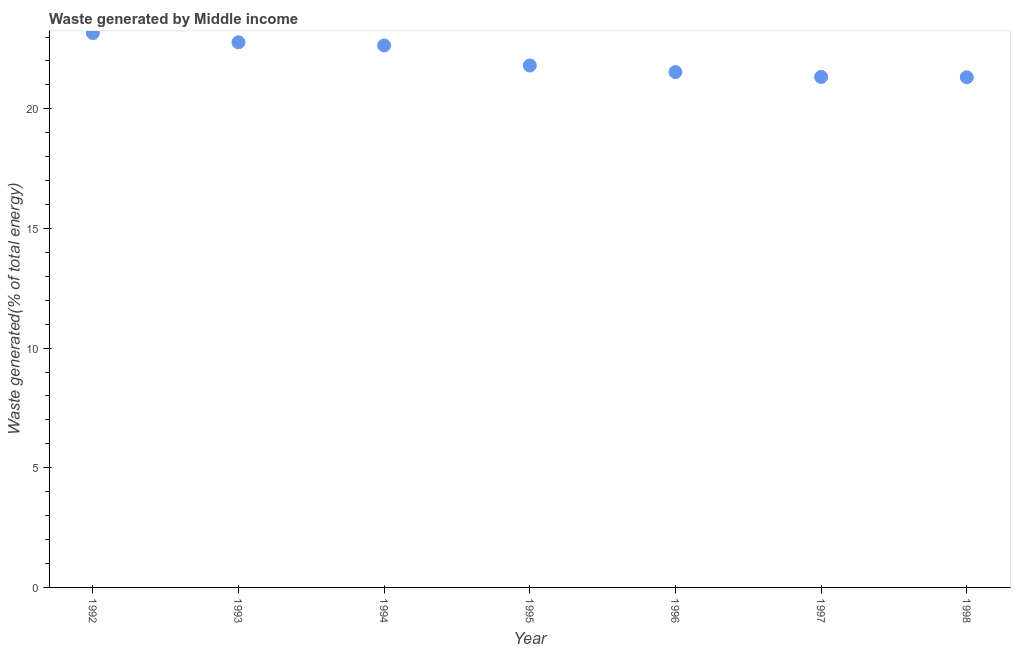What is the amount of waste generated in 1996?
Your response must be concise. 21.54. Across all years, what is the maximum amount of waste generated?
Your response must be concise. 23.17. Across all years, what is the minimum amount of waste generated?
Your answer should be very brief. 21.32. What is the sum of the amount of waste generated?
Provide a short and direct response. 154.59. What is the difference between the amount of waste generated in 1993 and 1998?
Provide a short and direct response. 1.46. What is the average amount of waste generated per year?
Provide a short and direct response. 22.08. What is the median amount of waste generated?
Keep it short and to the point. 21.81. In how many years, is the amount of waste generated greater than 20 %?
Keep it short and to the point. 7. What is the ratio of the amount of waste generated in 1993 to that in 1997?
Your answer should be compact. 1.07. Is the amount of waste generated in 1993 less than that in 1996?
Provide a succinct answer. No. Is the difference between the amount of waste generated in 1993 and 1996 greater than the difference between any two years?
Your answer should be compact. No. What is the difference between the highest and the second highest amount of waste generated?
Keep it short and to the point. 0.39. What is the difference between the highest and the lowest amount of waste generated?
Offer a terse response. 1.85. In how many years, is the amount of waste generated greater than the average amount of waste generated taken over all years?
Your response must be concise. 3. Does the amount of waste generated monotonically increase over the years?
Give a very brief answer. No. How many years are there in the graph?
Your answer should be very brief. 7. Are the values on the major ticks of Y-axis written in scientific E-notation?
Your answer should be compact. No. Does the graph contain any zero values?
Your response must be concise. No. What is the title of the graph?
Keep it short and to the point. Waste generated by Middle income. What is the label or title of the Y-axis?
Your answer should be very brief. Waste generated(% of total energy). What is the Waste generated(% of total energy) in 1992?
Offer a very short reply. 23.17. What is the Waste generated(% of total energy) in 1993?
Provide a short and direct response. 22.78. What is the Waste generated(% of total energy) in 1994?
Keep it short and to the point. 22.65. What is the Waste generated(% of total energy) in 1995?
Your answer should be compact. 21.81. What is the Waste generated(% of total energy) in 1996?
Make the answer very short. 21.54. What is the Waste generated(% of total energy) in 1997?
Your answer should be compact. 21.33. What is the Waste generated(% of total energy) in 1998?
Keep it short and to the point. 21.32. What is the difference between the Waste generated(% of total energy) in 1992 and 1993?
Give a very brief answer. 0.39. What is the difference between the Waste generated(% of total energy) in 1992 and 1994?
Give a very brief answer. 0.52. What is the difference between the Waste generated(% of total energy) in 1992 and 1995?
Your response must be concise. 1.36. What is the difference between the Waste generated(% of total energy) in 1992 and 1996?
Make the answer very short. 1.63. What is the difference between the Waste generated(% of total energy) in 1992 and 1997?
Offer a terse response. 1.84. What is the difference between the Waste generated(% of total energy) in 1992 and 1998?
Make the answer very short. 1.85. What is the difference between the Waste generated(% of total energy) in 1993 and 1994?
Your response must be concise. 0.13. What is the difference between the Waste generated(% of total energy) in 1993 and 1995?
Ensure brevity in your answer.  0.97. What is the difference between the Waste generated(% of total energy) in 1993 and 1996?
Your answer should be very brief. 1.25. What is the difference between the Waste generated(% of total energy) in 1993 and 1997?
Provide a succinct answer. 1.45. What is the difference between the Waste generated(% of total energy) in 1993 and 1998?
Give a very brief answer. 1.46. What is the difference between the Waste generated(% of total energy) in 1994 and 1995?
Provide a succinct answer. 0.84. What is the difference between the Waste generated(% of total energy) in 1994 and 1996?
Give a very brief answer. 1.11. What is the difference between the Waste generated(% of total energy) in 1994 and 1997?
Keep it short and to the point. 1.32. What is the difference between the Waste generated(% of total energy) in 1994 and 1998?
Provide a short and direct response. 1.33. What is the difference between the Waste generated(% of total energy) in 1995 and 1996?
Provide a succinct answer. 0.27. What is the difference between the Waste generated(% of total energy) in 1995 and 1997?
Your answer should be very brief. 0.48. What is the difference between the Waste generated(% of total energy) in 1995 and 1998?
Your answer should be very brief. 0.49. What is the difference between the Waste generated(% of total energy) in 1996 and 1997?
Make the answer very short. 0.2. What is the difference between the Waste generated(% of total energy) in 1996 and 1998?
Provide a short and direct response. 0.22. What is the difference between the Waste generated(% of total energy) in 1997 and 1998?
Your response must be concise. 0.01. What is the ratio of the Waste generated(% of total energy) in 1992 to that in 1995?
Offer a very short reply. 1.06. What is the ratio of the Waste generated(% of total energy) in 1992 to that in 1996?
Offer a terse response. 1.08. What is the ratio of the Waste generated(% of total energy) in 1992 to that in 1997?
Your response must be concise. 1.09. What is the ratio of the Waste generated(% of total energy) in 1992 to that in 1998?
Your answer should be very brief. 1.09. What is the ratio of the Waste generated(% of total energy) in 1993 to that in 1994?
Give a very brief answer. 1.01. What is the ratio of the Waste generated(% of total energy) in 1993 to that in 1995?
Your answer should be compact. 1.04. What is the ratio of the Waste generated(% of total energy) in 1993 to that in 1996?
Provide a short and direct response. 1.06. What is the ratio of the Waste generated(% of total energy) in 1993 to that in 1997?
Your answer should be compact. 1.07. What is the ratio of the Waste generated(% of total energy) in 1993 to that in 1998?
Give a very brief answer. 1.07. What is the ratio of the Waste generated(% of total energy) in 1994 to that in 1995?
Provide a succinct answer. 1.04. What is the ratio of the Waste generated(% of total energy) in 1994 to that in 1996?
Keep it short and to the point. 1.05. What is the ratio of the Waste generated(% of total energy) in 1994 to that in 1997?
Ensure brevity in your answer.  1.06. What is the ratio of the Waste generated(% of total energy) in 1994 to that in 1998?
Give a very brief answer. 1.06. What is the ratio of the Waste generated(% of total energy) in 1995 to that in 1996?
Your response must be concise. 1.01. What is the ratio of the Waste generated(% of total energy) in 1995 to that in 1997?
Give a very brief answer. 1.02. 